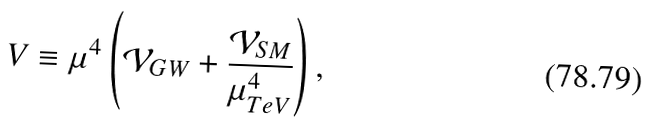<formula> <loc_0><loc_0><loc_500><loc_500>V \equiv \mu ^ { 4 } \left ( \mathcal { V } _ { G W } + \frac { \mathcal { V } _ { S M } } { \mu _ { T e V } ^ { 4 } } \right ) ,</formula> 